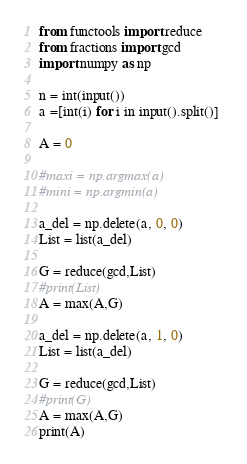Convert code to text. <code><loc_0><loc_0><loc_500><loc_500><_Python_>from functools import reduce
from fractions import gcd
import numpy as np

n = int(input())
a =[int(i) for i in input().split()] 

A = 0

#maxi = np.argmax(a)
#mini = np.argmin(a)

a_del = np.delete(a, 0, 0)
List = list(a_del)
  
G = reduce(gcd,List)
#print(List)
A = max(A,G)

a_del = np.delete(a, 1, 0)
List = list(a_del)
  
G = reduce(gcd,List)
#print(G)
A = max(A,G)
print(A)</code> 